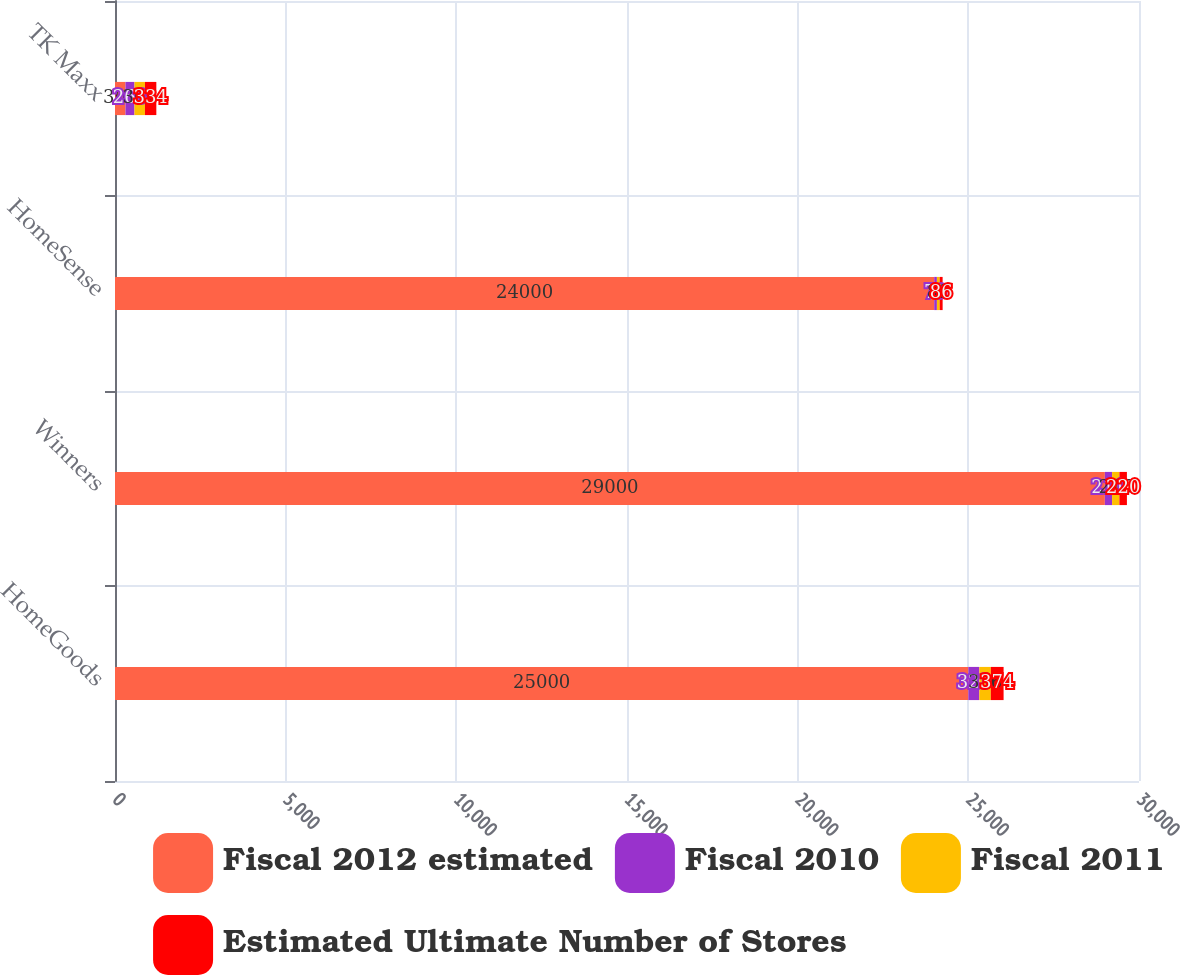Convert chart to OTSL. <chart><loc_0><loc_0><loc_500><loc_500><stacked_bar_chart><ecel><fcel>HomeGoods<fcel>Winners<fcel>HomeSense<fcel>TK Maxx<nl><fcel>Fiscal 2012 estimated<fcel>25000<fcel>29000<fcel>24000<fcel>307<nl><fcel>Fiscal 2010<fcel>323<fcel>211<fcel>79<fcel>263<nl><fcel>Fiscal 2011<fcel>336<fcel>215<fcel>82<fcel>307<nl><fcel>Estimated Ultimate Number of Stores<fcel>374<fcel>220<fcel>86<fcel>334<nl></chart> 